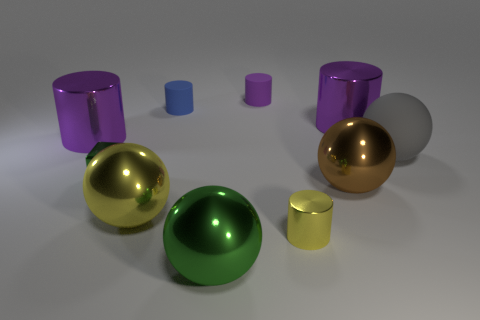Subtract all purple cylinders. How many were subtracted if there are1purple cylinders left? 2 Subtract all yellow blocks. How many purple cylinders are left? 3 Subtract all yellow cylinders. How many cylinders are left? 4 Subtract all small blue matte cylinders. How many cylinders are left? 4 Subtract all green cylinders. Subtract all blue balls. How many cylinders are left? 5 Subtract all cubes. How many objects are left? 9 Add 2 large yellow spheres. How many large yellow spheres exist? 3 Subtract 0 red blocks. How many objects are left? 10 Subtract all blue objects. Subtract all yellow metallic things. How many objects are left? 7 Add 8 green blocks. How many green blocks are left? 9 